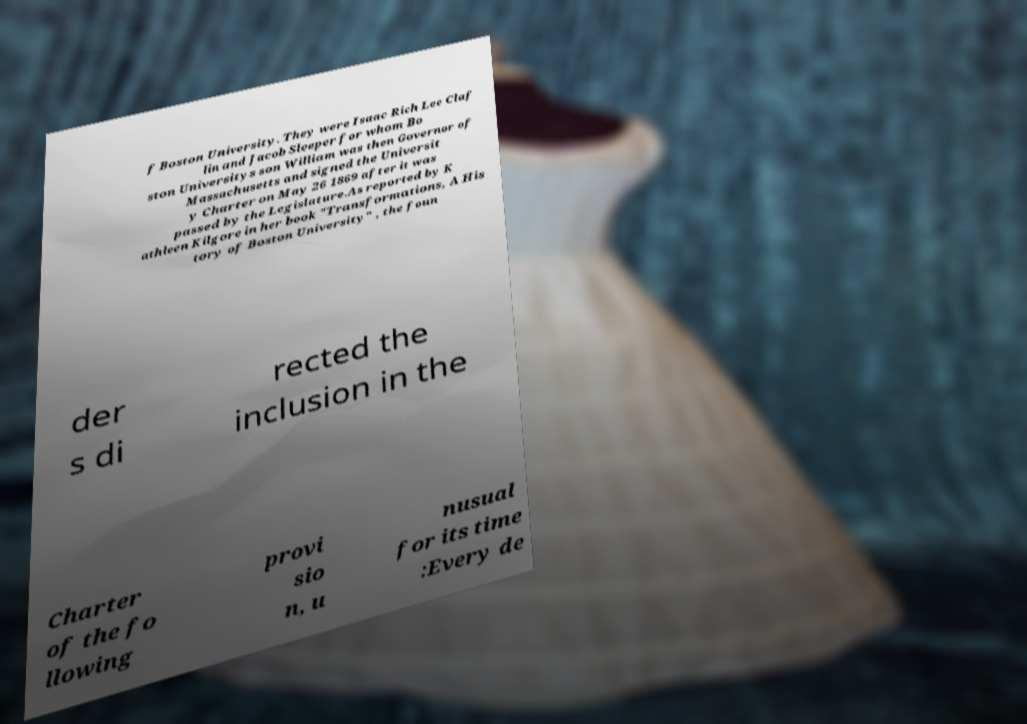Could you extract and type out the text from this image? f Boston University. They were Isaac Rich Lee Claf lin and Jacob Sleeper for whom Bo ston Universitys son William was then Governor of Massachusetts and signed the Universit y Charter on May 26 1869 after it was passed by the Legislature.As reported by K athleen Kilgore in her book "Transformations, A His tory of Boston University" , the foun der s di rected the inclusion in the Charter of the fo llowing provi sio n, u nusual for its time :Every de 